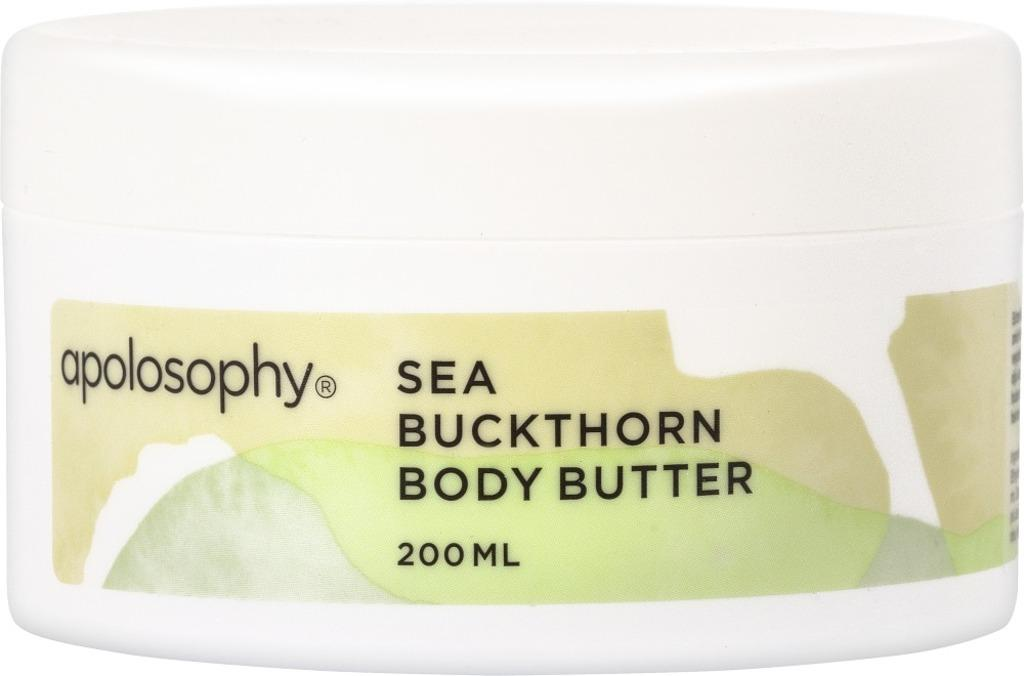<image>
Provide a brief description of the given image. A 200ml container of apolosophy buckthron body butter. 